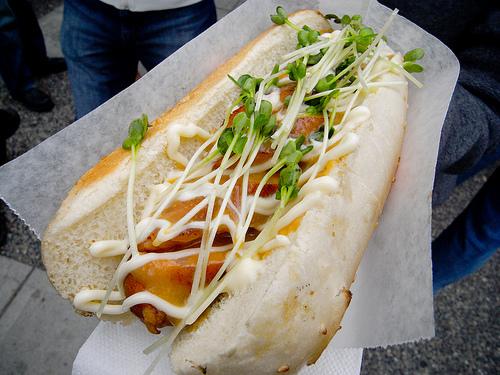What type of food is this?
Concise answer only. Hot dog. What condiment is on top of the hot dog?
Give a very brief answer. Mayo. What kind of sauce in this hot dog?
Answer briefly. Mayonnaise. Does the hotdog have catsup?
Be succinct. No. Does this food look healthy?
Give a very brief answer. No. Are there peppers on the hot dog?
Short answer required. No. What kind of herb is on top of the sandwich?
Give a very brief answer. Parsley. What milk by product is on this hot dog?
Answer briefly. Cheese. 